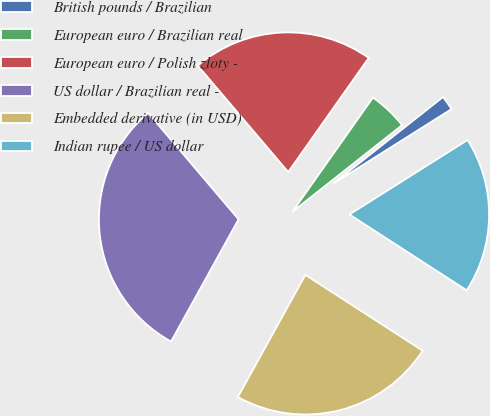Convert chart to OTSL. <chart><loc_0><loc_0><loc_500><loc_500><pie_chart><fcel>British pounds / Brazilian<fcel>European euro / Brazilian real<fcel>European euro / Polish zloty -<fcel>US dollar / Brazilian real -<fcel>Embedded derivative (in USD)<fcel>Indian rupee / US dollar<nl><fcel>1.68%<fcel>4.59%<fcel>20.99%<fcel>30.75%<fcel>23.9%<fcel>18.09%<nl></chart> 